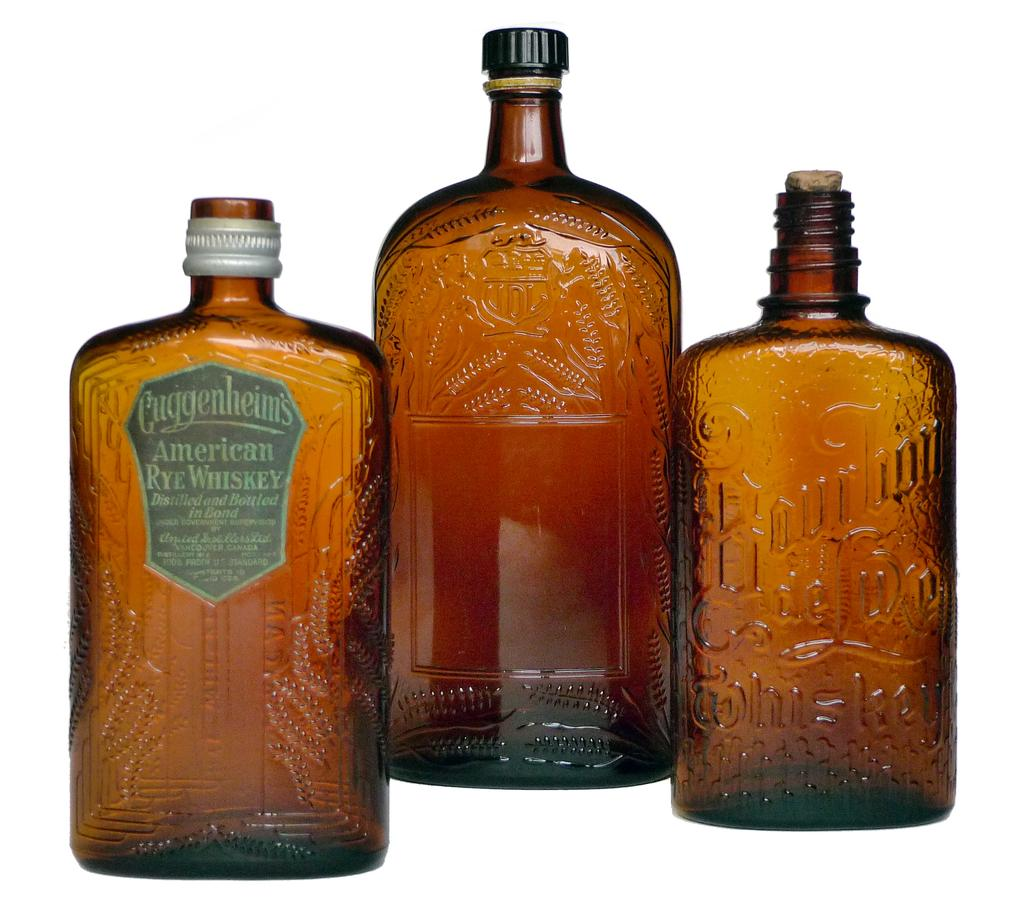How many glass bottles are visible in the image? There are three glass bottles in the image. What can be seen in the background of the image? The background of the image is white. What color is the orange bead used for in the image? There is no orange bead present in the image. 